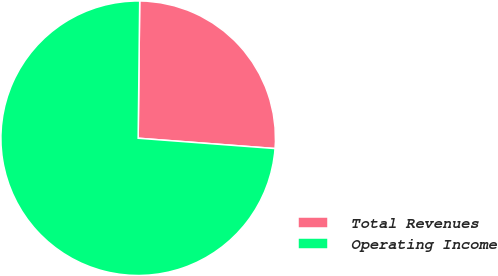Convert chart to OTSL. <chart><loc_0><loc_0><loc_500><loc_500><pie_chart><fcel>Total Revenues<fcel>Operating Income<nl><fcel>26.02%<fcel>73.98%<nl></chart> 